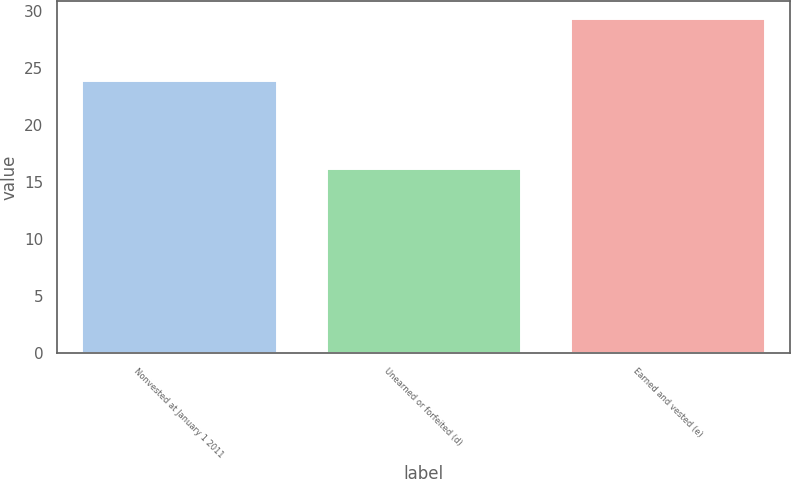<chart> <loc_0><loc_0><loc_500><loc_500><bar_chart><fcel>Nonvested at January 1 2011<fcel>Unearned or forfeited (d)<fcel>Earned and vested (e)<nl><fcel>23.96<fcel>16.28<fcel>29.47<nl></chart> 